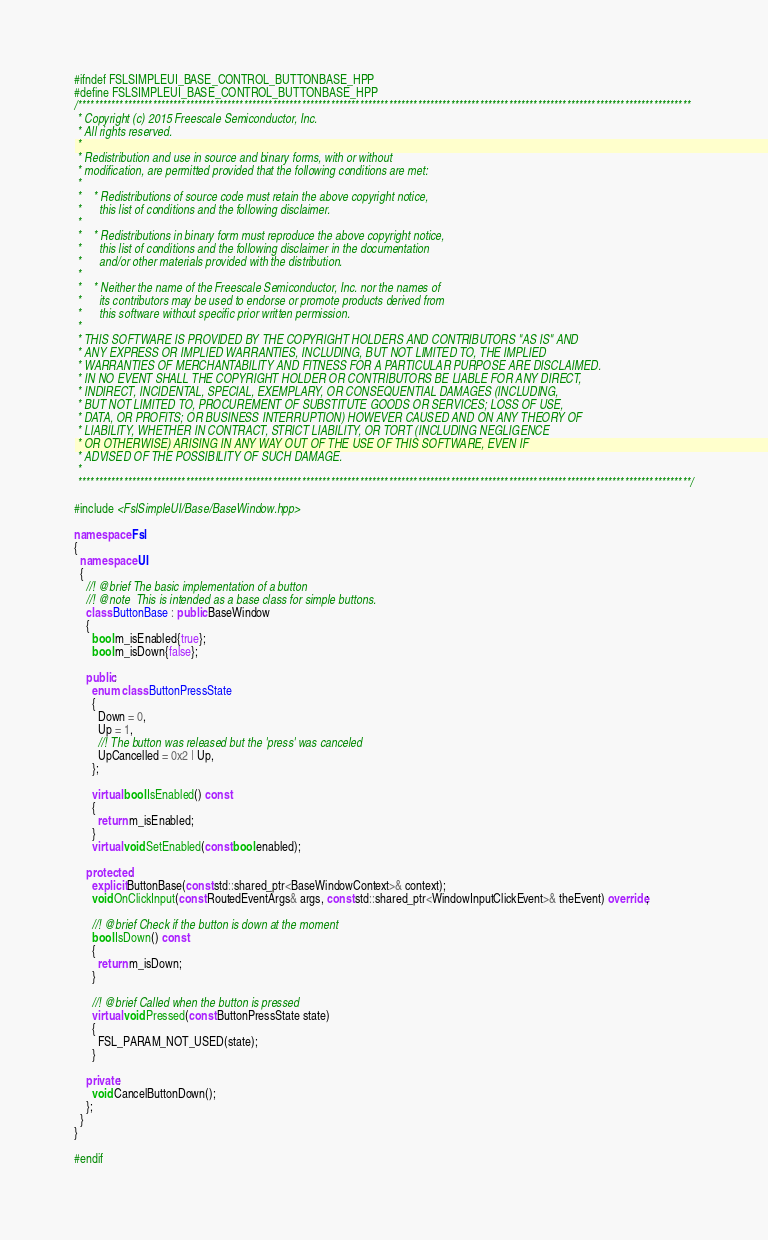Convert code to text. <code><loc_0><loc_0><loc_500><loc_500><_C++_>#ifndef FSLSIMPLEUI_BASE_CONTROL_BUTTONBASE_HPP
#define FSLSIMPLEUI_BASE_CONTROL_BUTTONBASE_HPP
/****************************************************************************************************************************************************
 * Copyright (c) 2015 Freescale Semiconductor, Inc.
 * All rights reserved.
 *
 * Redistribution and use in source and binary forms, with or without
 * modification, are permitted provided that the following conditions are met:
 *
 *    * Redistributions of source code must retain the above copyright notice,
 *      this list of conditions and the following disclaimer.
 *
 *    * Redistributions in binary form must reproduce the above copyright notice,
 *      this list of conditions and the following disclaimer in the documentation
 *      and/or other materials provided with the distribution.
 *
 *    * Neither the name of the Freescale Semiconductor, Inc. nor the names of
 *      its contributors may be used to endorse or promote products derived from
 *      this software without specific prior written permission.
 *
 * THIS SOFTWARE IS PROVIDED BY THE COPYRIGHT HOLDERS AND CONTRIBUTORS "AS IS" AND
 * ANY EXPRESS OR IMPLIED WARRANTIES, INCLUDING, BUT NOT LIMITED TO, THE IMPLIED
 * WARRANTIES OF MERCHANTABILITY AND FITNESS FOR A PARTICULAR PURPOSE ARE DISCLAIMED.
 * IN NO EVENT SHALL THE COPYRIGHT HOLDER OR CONTRIBUTORS BE LIABLE FOR ANY DIRECT,
 * INDIRECT, INCIDENTAL, SPECIAL, EXEMPLARY, OR CONSEQUENTIAL DAMAGES (INCLUDING,
 * BUT NOT LIMITED TO, PROCUREMENT OF SUBSTITUTE GOODS OR SERVICES; LOSS OF USE,
 * DATA, OR PROFITS; OR BUSINESS INTERRUPTION) HOWEVER CAUSED AND ON ANY THEORY OF
 * LIABILITY, WHETHER IN CONTRACT, STRICT LIABILITY, OR TORT (INCLUDING NEGLIGENCE
 * OR OTHERWISE) ARISING IN ANY WAY OUT OF THE USE OF THIS SOFTWARE, EVEN IF
 * ADVISED OF THE POSSIBILITY OF SUCH DAMAGE.
 *
 ****************************************************************************************************************************************************/

#include <FslSimpleUI/Base/BaseWindow.hpp>

namespace Fsl
{
  namespace UI
  {
    //! @brief The basic implementation of a button
    //! @note  This is intended as a base class for simple buttons.
    class ButtonBase : public BaseWindow
    {
      bool m_isEnabled{true};
      bool m_isDown{false};

    public:
      enum class ButtonPressState
      {
        Down = 0,
        Up = 1,
        //! The button was released but the 'press' was canceled
        UpCancelled = 0x2 | Up,
      };

      virtual bool IsEnabled() const
      {
        return m_isEnabled;
      }
      virtual void SetEnabled(const bool enabled);

    protected:
      explicit ButtonBase(const std::shared_ptr<BaseWindowContext>& context);
      void OnClickInput(const RoutedEventArgs& args, const std::shared_ptr<WindowInputClickEvent>& theEvent) override;

      //! @brief Check if the button is down at the moment
      bool IsDown() const
      {
        return m_isDown;
      }

      //! @brief Called when the button is pressed
      virtual void Pressed(const ButtonPressState state)
      {
        FSL_PARAM_NOT_USED(state);
      }

    private:
      void CancelButtonDown();
    };
  }
}

#endif
</code> 